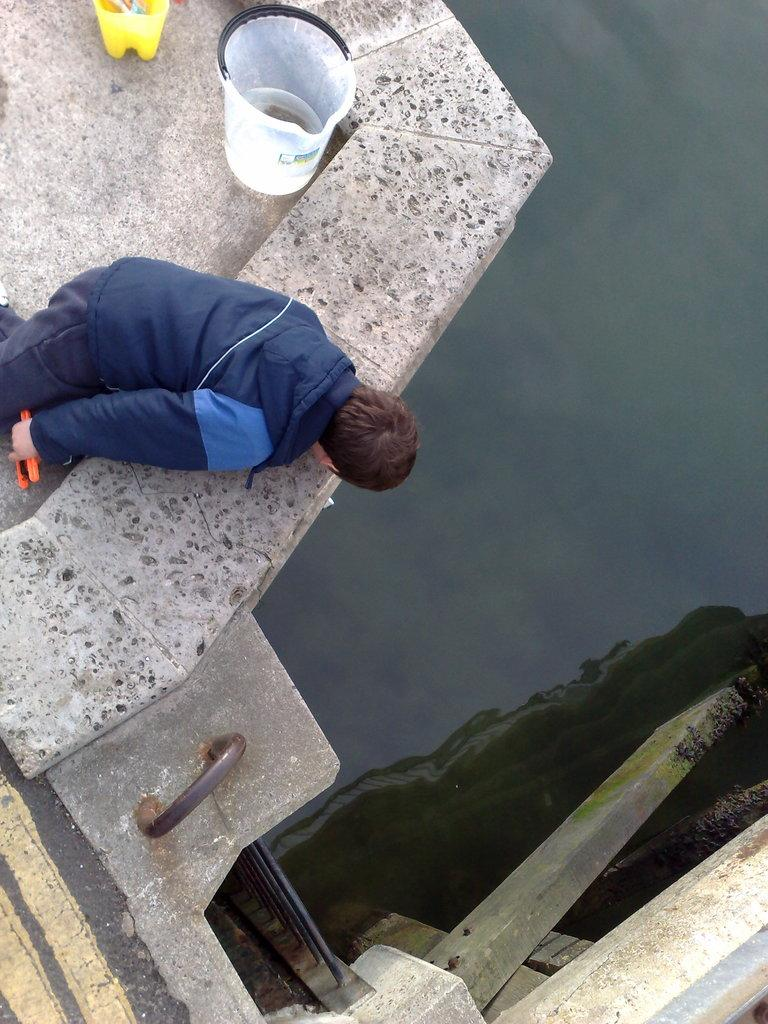Who or what is present in the image? There is a person in the image. What object can be seen in the image that is typically used for holding or carrying items? There is a bucket in the image. What are the long, thin objects in the image? There are rods in the image. What can be seen in the image that indicates the presence of water? There is water visible in the image. What other unspecified objects can be seen in the image? There are unspecified objects in the image. What type of farm animal can be seen interacting with the person in the image? There is no farm animal present in the image; it only features a person, a bucket, rods, water, and unspecified objects. 